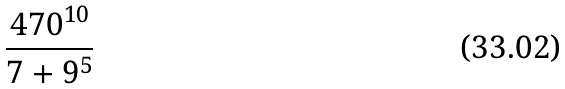Convert formula to latex. <formula><loc_0><loc_0><loc_500><loc_500>\frac { 4 7 0 ^ { 1 0 } } { 7 + 9 ^ { 5 } }</formula> 